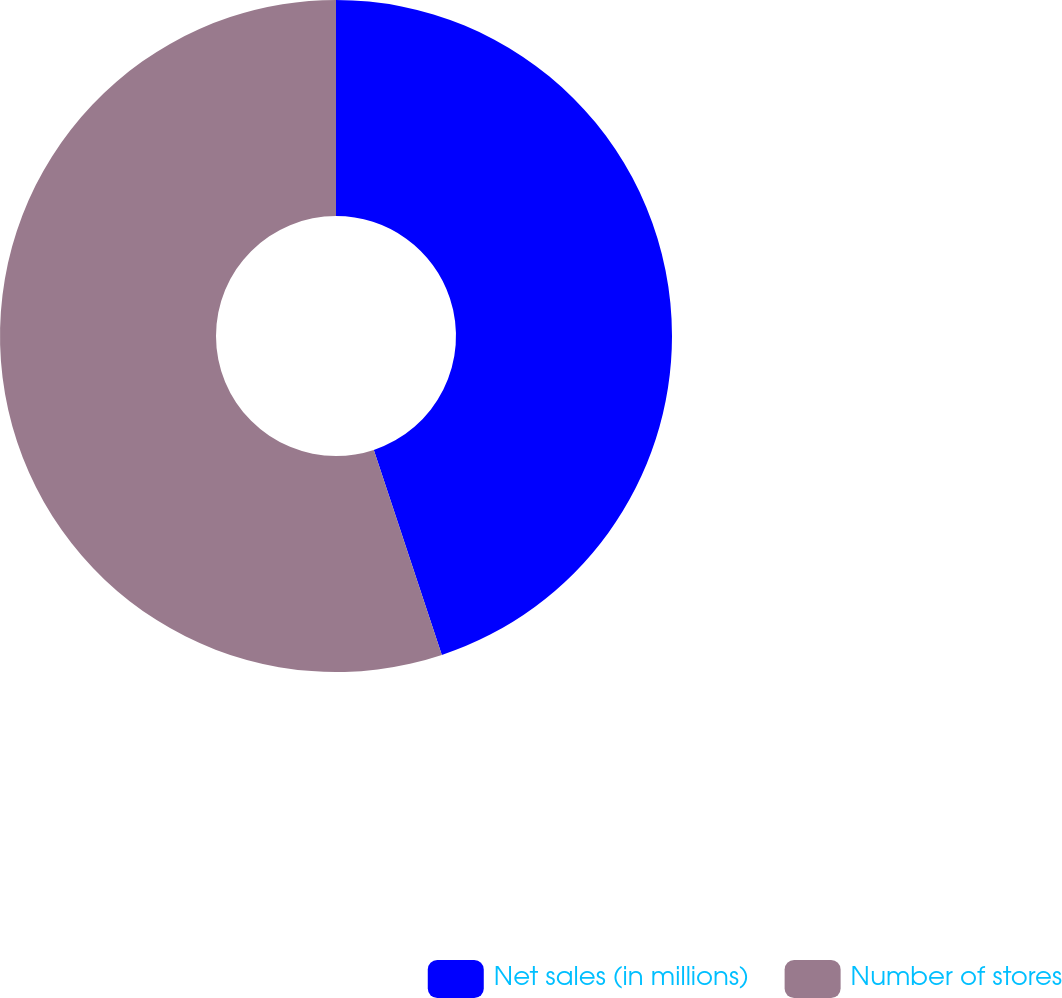<chart> <loc_0><loc_0><loc_500><loc_500><pie_chart><fcel>Net sales (in millions)<fcel>Number of stores<nl><fcel>44.9%<fcel>55.1%<nl></chart> 